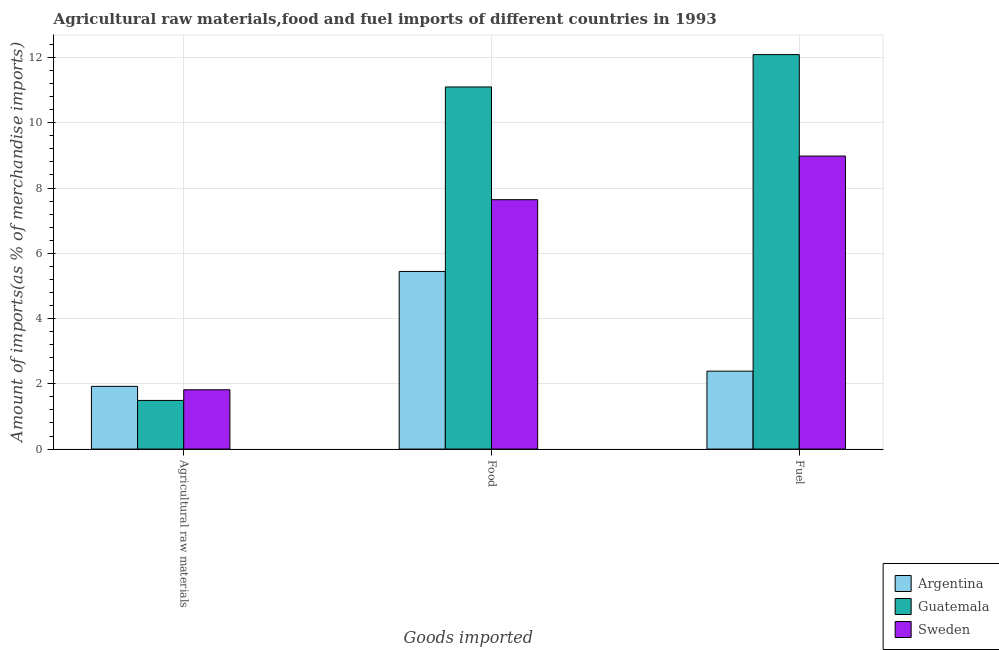How many different coloured bars are there?
Keep it short and to the point. 3. Are the number of bars on each tick of the X-axis equal?
Make the answer very short. Yes. How many bars are there on the 2nd tick from the left?
Keep it short and to the point. 3. What is the label of the 1st group of bars from the left?
Ensure brevity in your answer.  Agricultural raw materials. What is the percentage of raw materials imports in Guatemala?
Provide a short and direct response. 1.49. Across all countries, what is the maximum percentage of raw materials imports?
Provide a succinct answer. 1.92. Across all countries, what is the minimum percentage of food imports?
Your answer should be compact. 5.44. In which country was the percentage of food imports maximum?
Your response must be concise. Guatemala. In which country was the percentage of raw materials imports minimum?
Keep it short and to the point. Guatemala. What is the total percentage of food imports in the graph?
Provide a short and direct response. 24.18. What is the difference between the percentage of raw materials imports in Argentina and that in Sweden?
Make the answer very short. 0.1. What is the difference between the percentage of fuel imports in Guatemala and the percentage of raw materials imports in Argentina?
Make the answer very short. 10.17. What is the average percentage of food imports per country?
Make the answer very short. 8.06. What is the difference between the percentage of fuel imports and percentage of raw materials imports in Guatemala?
Your answer should be compact. 10.6. What is the ratio of the percentage of food imports in Sweden to that in Argentina?
Make the answer very short. 1.4. Is the percentage of food imports in Guatemala less than that in Sweden?
Offer a terse response. No. What is the difference between the highest and the second highest percentage of food imports?
Ensure brevity in your answer.  3.45. What is the difference between the highest and the lowest percentage of fuel imports?
Provide a succinct answer. 9.7. What does the 2nd bar from the right in Food represents?
Your answer should be very brief. Guatemala. Is it the case that in every country, the sum of the percentage of raw materials imports and percentage of food imports is greater than the percentage of fuel imports?
Offer a terse response. Yes. How many bars are there?
Offer a very short reply. 9. Are the values on the major ticks of Y-axis written in scientific E-notation?
Offer a very short reply. No. Does the graph contain any zero values?
Make the answer very short. No. How many legend labels are there?
Make the answer very short. 3. What is the title of the graph?
Give a very brief answer. Agricultural raw materials,food and fuel imports of different countries in 1993. What is the label or title of the X-axis?
Offer a terse response. Goods imported. What is the label or title of the Y-axis?
Provide a short and direct response. Amount of imports(as % of merchandise imports). What is the Amount of imports(as % of merchandise imports) in Argentina in Agricultural raw materials?
Offer a very short reply. 1.92. What is the Amount of imports(as % of merchandise imports) of Guatemala in Agricultural raw materials?
Offer a very short reply. 1.49. What is the Amount of imports(as % of merchandise imports) of Sweden in Agricultural raw materials?
Provide a succinct answer. 1.82. What is the Amount of imports(as % of merchandise imports) in Argentina in Food?
Make the answer very short. 5.44. What is the Amount of imports(as % of merchandise imports) of Guatemala in Food?
Your response must be concise. 11.1. What is the Amount of imports(as % of merchandise imports) in Sweden in Food?
Keep it short and to the point. 7.64. What is the Amount of imports(as % of merchandise imports) of Argentina in Fuel?
Your response must be concise. 2.39. What is the Amount of imports(as % of merchandise imports) of Guatemala in Fuel?
Your response must be concise. 12.09. What is the Amount of imports(as % of merchandise imports) of Sweden in Fuel?
Make the answer very short. 8.98. Across all Goods imported, what is the maximum Amount of imports(as % of merchandise imports) of Argentina?
Your response must be concise. 5.44. Across all Goods imported, what is the maximum Amount of imports(as % of merchandise imports) of Guatemala?
Offer a terse response. 12.09. Across all Goods imported, what is the maximum Amount of imports(as % of merchandise imports) in Sweden?
Ensure brevity in your answer.  8.98. Across all Goods imported, what is the minimum Amount of imports(as % of merchandise imports) in Argentina?
Make the answer very short. 1.92. Across all Goods imported, what is the minimum Amount of imports(as % of merchandise imports) of Guatemala?
Offer a terse response. 1.49. Across all Goods imported, what is the minimum Amount of imports(as % of merchandise imports) of Sweden?
Give a very brief answer. 1.82. What is the total Amount of imports(as % of merchandise imports) of Argentina in the graph?
Your answer should be compact. 9.75. What is the total Amount of imports(as % of merchandise imports) of Guatemala in the graph?
Make the answer very short. 24.67. What is the total Amount of imports(as % of merchandise imports) in Sweden in the graph?
Ensure brevity in your answer.  18.44. What is the difference between the Amount of imports(as % of merchandise imports) of Argentina in Agricultural raw materials and that in Food?
Your answer should be very brief. -3.52. What is the difference between the Amount of imports(as % of merchandise imports) of Guatemala in Agricultural raw materials and that in Food?
Ensure brevity in your answer.  -9.61. What is the difference between the Amount of imports(as % of merchandise imports) of Sweden in Agricultural raw materials and that in Food?
Offer a terse response. -5.82. What is the difference between the Amount of imports(as % of merchandise imports) in Argentina in Agricultural raw materials and that in Fuel?
Keep it short and to the point. -0.47. What is the difference between the Amount of imports(as % of merchandise imports) of Guatemala in Agricultural raw materials and that in Fuel?
Provide a short and direct response. -10.6. What is the difference between the Amount of imports(as % of merchandise imports) in Sweden in Agricultural raw materials and that in Fuel?
Your answer should be very brief. -7.16. What is the difference between the Amount of imports(as % of merchandise imports) in Argentina in Food and that in Fuel?
Keep it short and to the point. 3.06. What is the difference between the Amount of imports(as % of merchandise imports) in Guatemala in Food and that in Fuel?
Your response must be concise. -0.99. What is the difference between the Amount of imports(as % of merchandise imports) in Sweden in Food and that in Fuel?
Ensure brevity in your answer.  -1.34. What is the difference between the Amount of imports(as % of merchandise imports) of Argentina in Agricultural raw materials and the Amount of imports(as % of merchandise imports) of Guatemala in Food?
Provide a succinct answer. -9.17. What is the difference between the Amount of imports(as % of merchandise imports) in Argentina in Agricultural raw materials and the Amount of imports(as % of merchandise imports) in Sweden in Food?
Your answer should be very brief. -5.72. What is the difference between the Amount of imports(as % of merchandise imports) of Guatemala in Agricultural raw materials and the Amount of imports(as % of merchandise imports) of Sweden in Food?
Keep it short and to the point. -6.15. What is the difference between the Amount of imports(as % of merchandise imports) of Argentina in Agricultural raw materials and the Amount of imports(as % of merchandise imports) of Guatemala in Fuel?
Provide a short and direct response. -10.17. What is the difference between the Amount of imports(as % of merchandise imports) in Argentina in Agricultural raw materials and the Amount of imports(as % of merchandise imports) in Sweden in Fuel?
Your response must be concise. -7.06. What is the difference between the Amount of imports(as % of merchandise imports) in Guatemala in Agricultural raw materials and the Amount of imports(as % of merchandise imports) in Sweden in Fuel?
Ensure brevity in your answer.  -7.49. What is the difference between the Amount of imports(as % of merchandise imports) in Argentina in Food and the Amount of imports(as % of merchandise imports) in Guatemala in Fuel?
Ensure brevity in your answer.  -6.64. What is the difference between the Amount of imports(as % of merchandise imports) in Argentina in Food and the Amount of imports(as % of merchandise imports) in Sweden in Fuel?
Keep it short and to the point. -3.54. What is the difference between the Amount of imports(as % of merchandise imports) in Guatemala in Food and the Amount of imports(as % of merchandise imports) in Sweden in Fuel?
Your response must be concise. 2.12. What is the average Amount of imports(as % of merchandise imports) in Argentina per Goods imported?
Ensure brevity in your answer.  3.25. What is the average Amount of imports(as % of merchandise imports) in Guatemala per Goods imported?
Your response must be concise. 8.22. What is the average Amount of imports(as % of merchandise imports) in Sweden per Goods imported?
Give a very brief answer. 6.15. What is the difference between the Amount of imports(as % of merchandise imports) of Argentina and Amount of imports(as % of merchandise imports) of Guatemala in Agricultural raw materials?
Ensure brevity in your answer.  0.43. What is the difference between the Amount of imports(as % of merchandise imports) in Argentina and Amount of imports(as % of merchandise imports) in Sweden in Agricultural raw materials?
Keep it short and to the point. 0.1. What is the difference between the Amount of imports(as % of merchandise imports) in Guatemala and Amount of imports(as % of merchandise imports) in Sweden in Agricultural raw materials?
Your answer should be compact. -0.33. What is the difference between the Amount of imports(as % of merchandise imports) of Argentina and Amount of imports(as % of merchandise imports) of Guatemala in Food?
Make the answer very short. -5.65. What is the difference between the Amount of imports(as % of merchandise imports) of Argentina and Amount of imports(as % of merchandise imports) of Sweden in Food?
Give a very brief answer. -2.2. What is the difference between the Amount of imports(as % of merchandise imports) of Guatemala and Amount of imports(as % of merchandise imports) of Sweden in Food?
Provide a succinct answer. 3.45. What is the difference between the Amount of imports(as % of merchandise imports) in Argentina and Amount of imports(as % of merchandise imports) in Guatemala in Fuel?
Your answer should be very brief. -9.7. What is the difference between the Amount of imports(as % of merchandise imports) of Argentina and Amount of imports(as % of merchandise imports) of Sweden in Fuel?
Provide a succinct answer. -6.59. What is the difference between the Amount of imports(as % of merchandise imports) in Guatemala and Amount of imports(as % of merchandise imports) in Sweden in Fuel?
Offer a very short reply. 3.11. What is the ratio of the Amount of imports(as % of merchandise imports) in Argentina in Agricultural raw materials to that in Food?
Give a very brief answer. 0.35. What is the ratio of the Amount of imports(as % of merchandise imports) in Guatemala in Agricultural raw materials to that in Food?
Provide a succinct answer. 0.13. What is the ratio of the Amount of imports(as % of merchandise imports) of Sweden in Agricultural raw materials to that in Food?
Give a very brief answer. 0.24. What is the ratio of the Amount of imports(as % of merchandise imports) in Argentina in Agricultural raw materials to that in Fuel?
Give a very brief answer. 0.8. What is the ratio of the Amount of imports(as % of merchandise imports) of Guatemala in Agricultural raw materials to that in Fuel?
Provide a short and direct response. 0.12. What is the ratio of the Amount of imports(as % of merchandise imports) of Sweden in Agricultural raw materials to that in Fuel?
Give a very brief answer. 0.2. What is the ratio of the Amount of imports(as % of merchandise imports) in Argentina in Food to that in Fuel?
Offer a terse response. 2.28. What is the ratio of the Amount of imports(as % of merchandise imports) of Guatemala in Food to that in Fuel?
Keep it short and to the point. 0.92. What is the ratio of the Amount of imports(as % of merchandise imports) in Sweden in Food to that in Fuel?
Ensure brevity in your answer.  0.85. What is the difference between the highest and the second highest Amount of imports(as % of merchandise imports) in Argentina?
Make the answer very short. 3.06. What is the difference between the highest and the second highest Amount of imports(as % of merchandise imports) of Guatemala?
Provide a short and direct response. 0.99. What is the difference between the highest and the second highest Amount of imports(as % of merchandise imports) in Sweden?
Provide a succinct answer. 1.34. What is the difference between the highest and the lowest Amount of imports(as % of merchandise imports) in Argentina?
Give a very brief answer. 3.52. What is the difference between the highest and the lowest Amount of imports(as % of merchandise imports) of Guatemala?
Give a very brief answer. 10.6. What is the difference between the highest and the lowest Amount of imports(as % of merchandise imports) in Sweden?
Provide a succinct answer. 7.16. 